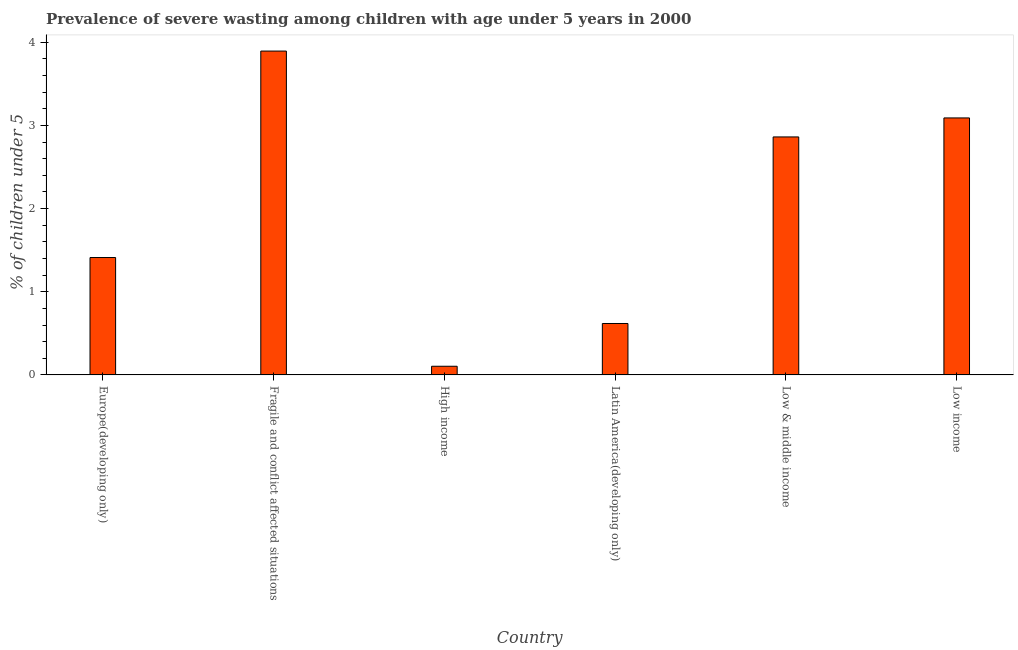Does the graph contain grids?
Give a very brief answer. No. What is the title of the graph?
Provide a short and direct response. Prevalence of severe wasting among children with age under 5 years in 2000. What is the label or title of the Y-axis?
Give a very brief answer.  % of children under 5. What is the prevalence of severe wasting in Latin America(developing only)?
Ensure brevity in your answer.  0.62. Across all countries, what is the maximum prevalence of severe wasting?
Offer a very short reply. 3.89. Across all countries, what is the minimum prevalence of severe wasting?
Give a very brief answer. 0.1. In which country was the prevalence of severe wasting maximum?
Make the answer very short. Fragile and conflict affected situations. What is the sum of the prevalence of severe wasting?
Make the answer very short. 11.98. What is the difference between the prevalence of severe wasting in Fragile and conflict affected situations and Latin America(developing only)?
Offer a very short reply. 3.28. What is the average prevalence of severe wasting per country?
Your answer should be very brief. 2. What is the median prevalence of severe wasting?
Keep it short and to the point. 2.14. Is the difference between the prevalence of severe wasting in Europe(developing only) and Low income greater than the difference between any two countries?
Provide a succinct answer. No. What is the difference between the highest and the second highest prevalence of severe wasting?
Provide a short and direct response. 0.8. What is the difference between the highest and the lowest prevalence of severe wasting?
Your answer should be very brief. 3.79. In how many countries, is the prevalence of severe wasting greater than the average prevalence of severe wasting taken over all countries?
Make the answer very short. 3. How many bars are there?
Make the answer very short. 6. Are all the bars in the graph horizontal?
Make the answer very short. No. What is the  % of children under 5 of Europe(developing only)?
Give a very brief answer. 1.41. What is the  % of children under 5 of Fragile and conflict affected situations?
Your answer should be compact. 3.89. What is the  % of children under 5 of High income?
Offer a very short reply. 0.1. What is the  % of children under 5 in Latin America(developing only)?
Your response must be concise. 0.62. What is the  % of children under 5 in Low & middle income?
Keep it short and to the point. 2.86. What is the  % of children under 5 in Low income?
Offer a very short reply. 3.09. What is the difference between the  % of children under 5 in Europe(developing only) and Fragile and conflict affected situations?
Ensure brevity in your answer.  -2.48. What is the difference between the  % of children under 5 in Europe(developing only) and High income?
Keep it short and to the point. 1.31. What is the difference between the  % of children under 5 in Europe(developing only) and Latin America(developing only)?
Provide a succinct answer. 0.79. What is the difference between the  % of children under 5 in Europe(developing only) and Low & middle income?
Your answer should be compact. -1.45. What is the difference between the  % of children under 5 in Europe(developing only) and Low income?
Your answer should be very brief. -1.68. What is the difference between the  % of children under 5 in Fragile and conflict affected situations and High income?
Make the answer very short. 3.79. What is the difference between the  % of children under 5 in Fragile and conflict affected situations and Latin America(developing only)?
Offer a very short reply. 3.28. What is the difference between the  % of children under 5 in Fragile and conflict affected situations and Low & middle income?
Give a very brief answer. 1.03. What is the difference between the  % of children under 5 in Fragile and conflict affected situations and Low income?
Make the answer very short. 0.8. What is the difference between the  % of children under 5 in High income and Latin America(developing only)?
Keep it short and to the point. -0.51. What is the difference between the  % of children under 5 in High income and Low & middle income?
Provide a short and direct response. -2.76. What is the difference between the  % of children under 5 in High income and Low income?
Give a very brief answer. -2.99. What is the difference between the  % of children under 5 in Latin America(developing only) and Low & middle income?
Keep it short and to the point. -2.24. What is the difference between the  % of children under 5 in Latin America(developing only) and Low income?
Your answer should be very brief. -2.47. What is the difference between the  % of children under 5 in Low & middle income and Low income?
Provide a short and direct response. -0.23. What is the ratio of the  % of children under 5 in Europe(developing only) to that in Fragile and conflict affected situations?
Offer a terse response. 0.36. What is the ratio of the  % of children under 5 in Europe(developing only) to that in High income?
Your response must be concise. 13.57. What is the ratio of the  % of children under 5 in Europe(developing only) to that in Latin America(developing only)?
Offer a very short reply. 2.28. What is the ratio of the  % of children under 5 in Europe(developing only) to that in Low & middle income?
Give a very brief answer. 0.49. What is the ratio of the  % of children under 5 in Europe(developing only) to that in Low income?
Make the answer very short. 0.46. What is the ratio of the  % of children under 5 in Fragile and conflict affected situations to that in High income?
Your answer should be very brief. 37.45. What is the ratio of the  % of children under 5 in Fragile and conflict affected situations to that in Latin America(developing only)?
Your answer should be compact. 6.3. What is the ratio of the  % of children under 5 in Fragile and conflict affected situations to that in Low & middle income?
Your answer should be compact. 1.36. What is the ratio of the  % of children under 5 in Fragile and conflict affected situations to that in Low income?
Offer a terse response. 1.26. What is the ratio of the  % of children under 5 in High income to that in Latin America(developing only)?
Ensure brevity in your answer.  0.17. What is the ratio of the  % of children under 5 in High income to that in Low & middle income?
Provide a short and direct response. 0.04. What is the ratio of the  % of children under 5 in High income to that in Low income?
Offer a very short reply. 0.03. What is the ratio of the  % of children under 5 in Latin America(developing only) to that in Low & middle income?
Give a very brief answer. 0.22. What is the ratio of the  % of children under 5 in Low & middle income to that in Low income?
Offer a terse response. 0.93. 